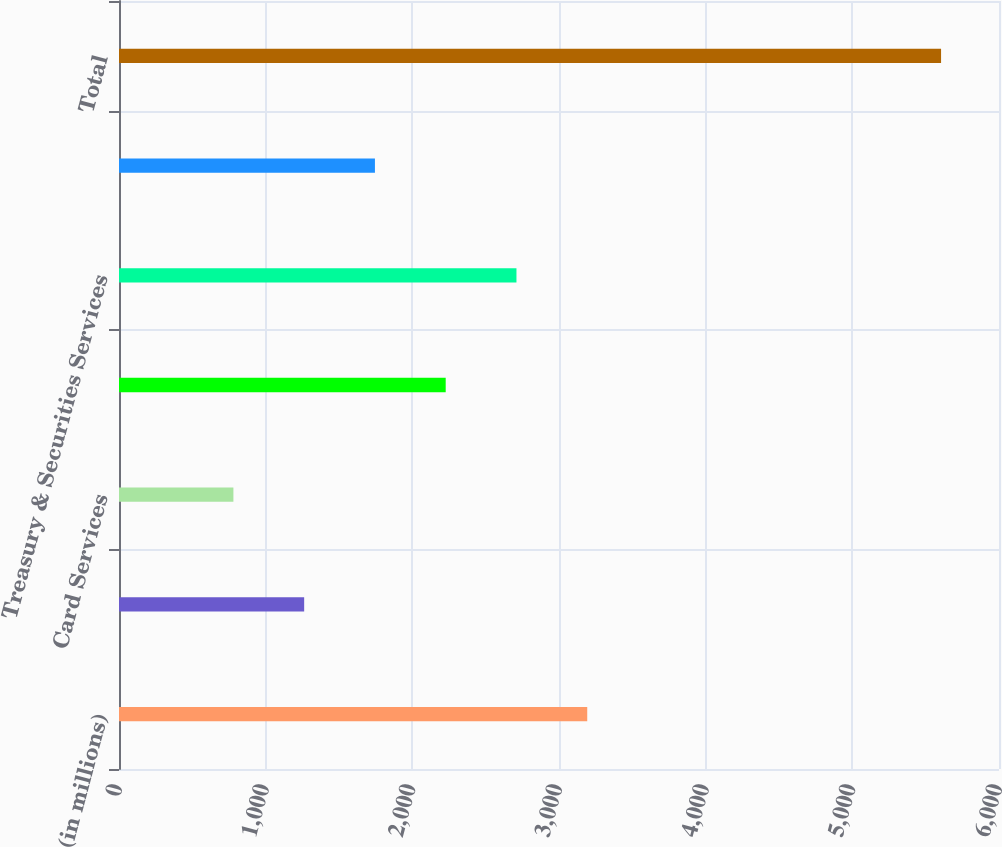<chart> <loc_0><loc_0><loc_500><loc_500><bar_chart><fcel>(in millions)<fcel>Investment Bank (b)<fcel>Card Services<fcel>Commercial Banking<fcel>Treasury & Securities Services<fcel>Asset Management<fcel>Total<nl><fcel>3192.5<fcel>1262.5<fcel>780<fcel>2227.5<fcel>2710<fcel>1745<fcel>5605<nl></chart> 